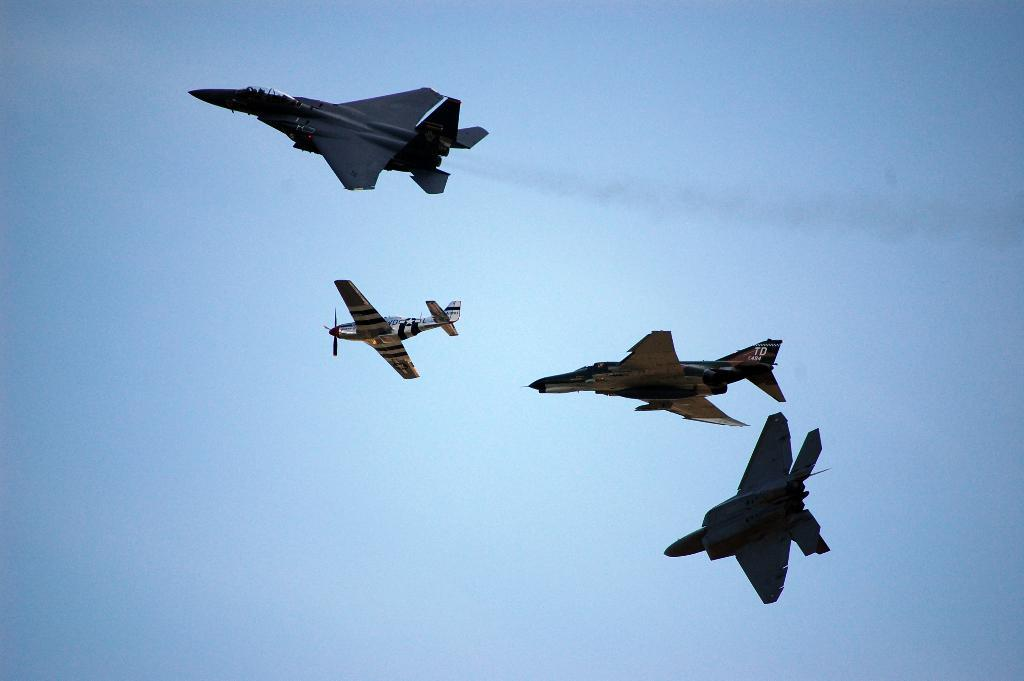How many aircrafts are visible in the image? There are four aircrafts in the image. What are the aircrafts doing in the image? The aircrafts are flying in the sky. What route are the pigs flying in the image? There are no pigs present in the image, and therefore no route can be determined for them. 